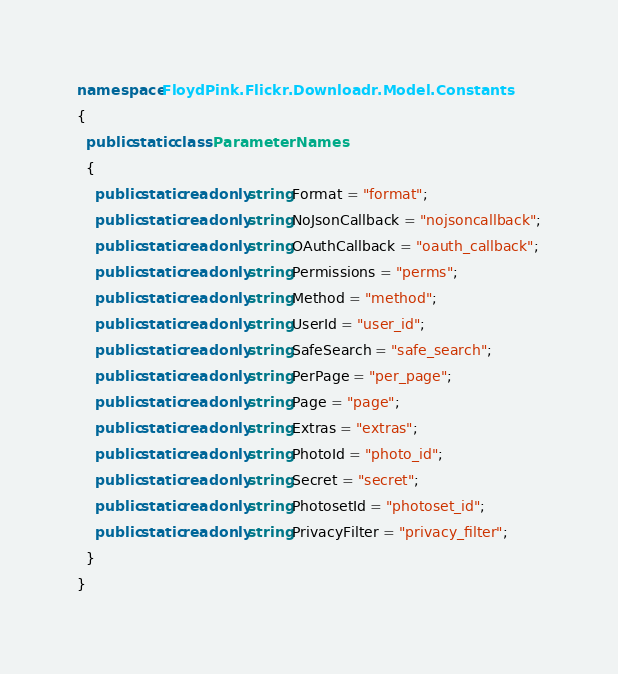Convert code to text. <code><loc_0><loc_0><loc_500><loc_500><_C#_>namespace FloydPink.Flickr.Downloadr.Model.Constants
{
  public static class ParameterNames
  {
    public static readonly string Format = "format";
    public static readonly string NoJsonCallback = "nojsoncallback";
    public static readonly string OAuthCallback = "oauth_callback";
    public static readonly string Permissions = "perms";
    public static readonly string Method = "method";
    public static readonly string UserId = "user_id";
    public static readonly string SafeSearch = "safe_search";
    public static readonly string PerPage = "per_page";
    public static readonly string Page = "page";
    public static readonly string Extras = "extras";
    public static readonly string PhotoId = "photo_id";
    public static readonly string Secret = "secret";
    public static readonly string PhotosetId = "photoset_id";
    public static readonly string PrivacyFilter = "privacy_filter";
  }
}
</code> 